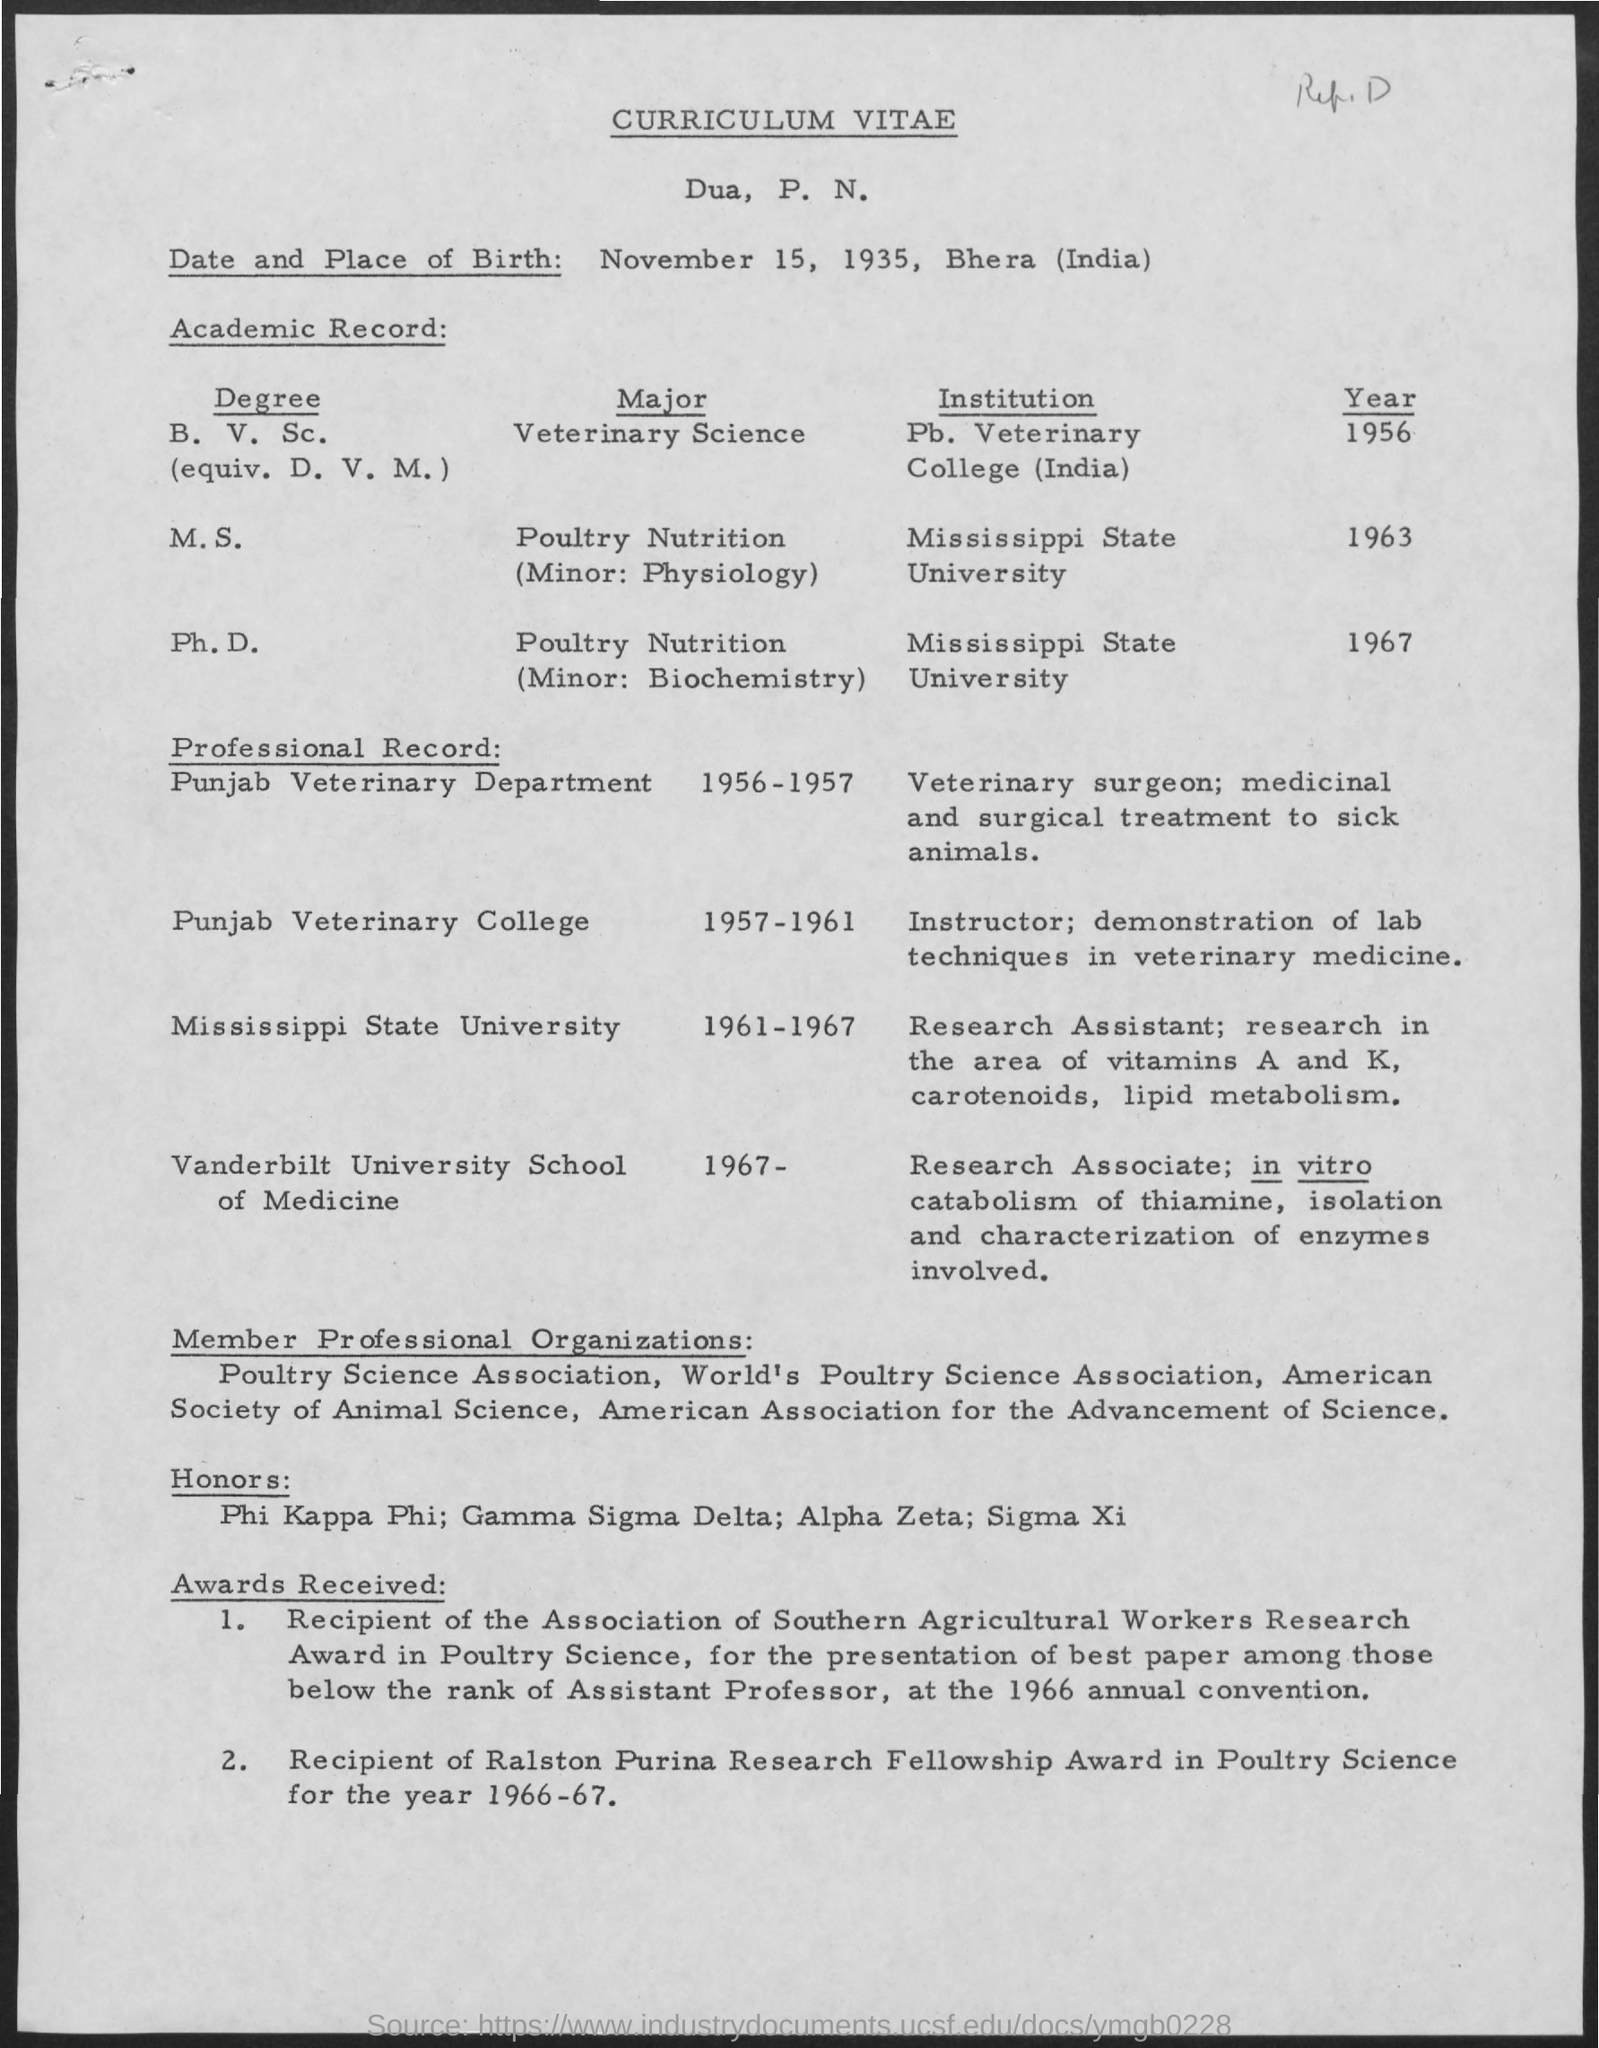Identify some key points in this picture. P. N. Dua, a veterinary surgeon at the Punjab Veterinary Department, performed various medical and surgical procedures to treat sick animals. During the years 1961-1967, Dua, P. N. held the job title of Research Assistant. Dua, P. N. has completed a Ph.D. degree at Mississippi State University. Dua, P. N., an instructor at Punjab Veterinary College, carried out the duty of demonstrating laboratory techniques in veterinary medicine. The curriculum vitae of "Whose" is given here. It is of Dua, P. N... 